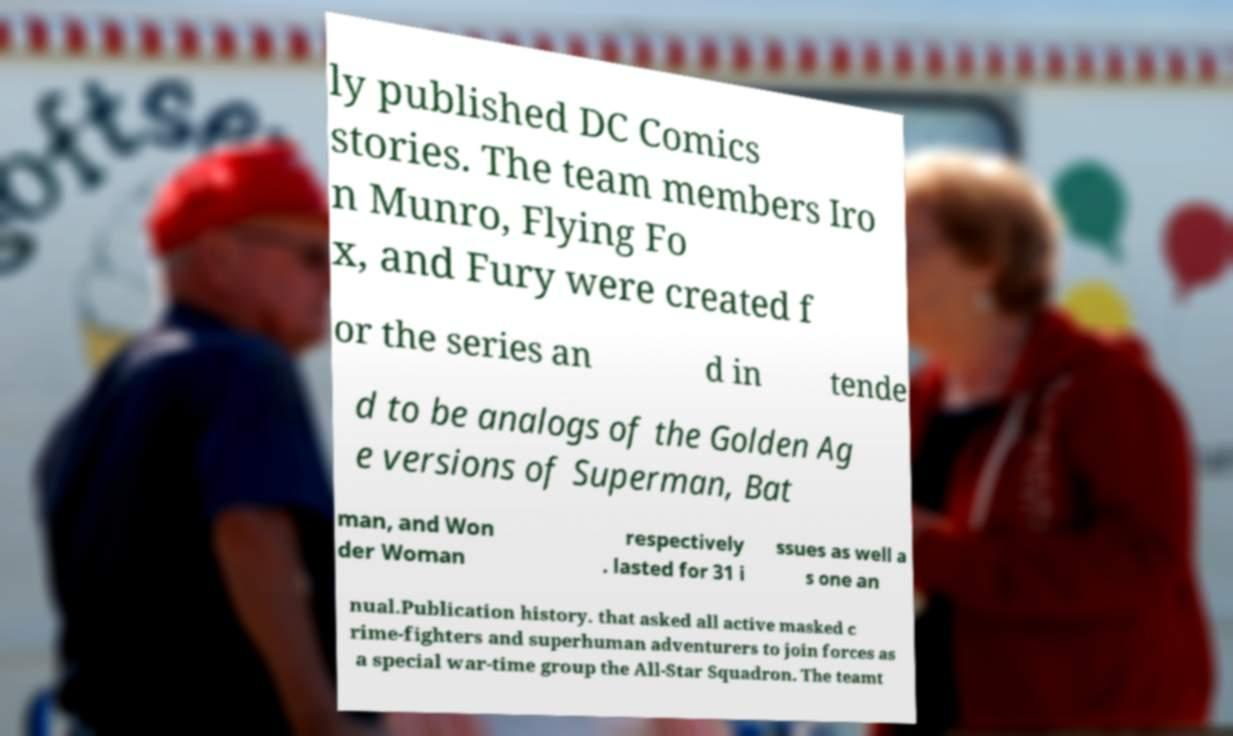Can you read and provide the text displayed in the image?This photo seems to have some interesting text. Can you extract and type it out for me? ly published DC Comics stories. The team members Iro n Munro, Flying Fo x, and Fury were created f or the series an d in tende d to be analogs of the Golden Ag e versions of Superman, Bat man, and Won der Woman respectively . lasted for 31 i ssues as well a s one an nual.Publication history. that asked all active masked c rime-fighters and superhuman adventurers to join forces as a special war-time group the All-Star Squadron. The teamt 